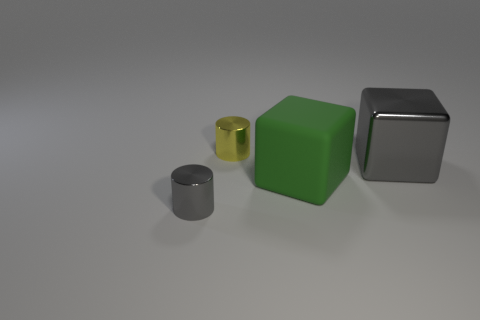Subtract 1 cubes. How many cubes are left? 1 Add 4 large yellow rubber blocks. How many objects exist? 8 Subtract all gray cylinders. How many cylinders are left? 1 Add 1 large yellow rubber things. How many large yellow rubber things exist? 1 Subtract 0 green cylinders. How many objects are left? 4 Subtract all blue cubes. Subtract all green spheres. How many cubes are left? 2 Subtract all gray spheres. How many purple cylinders are left? 0 Subtract all green blocks. Subtract all big gray shiny blocks. How many objects are left? 2 Add 2 gray metal cylinders. How many gray metal cylinders are left? 3 